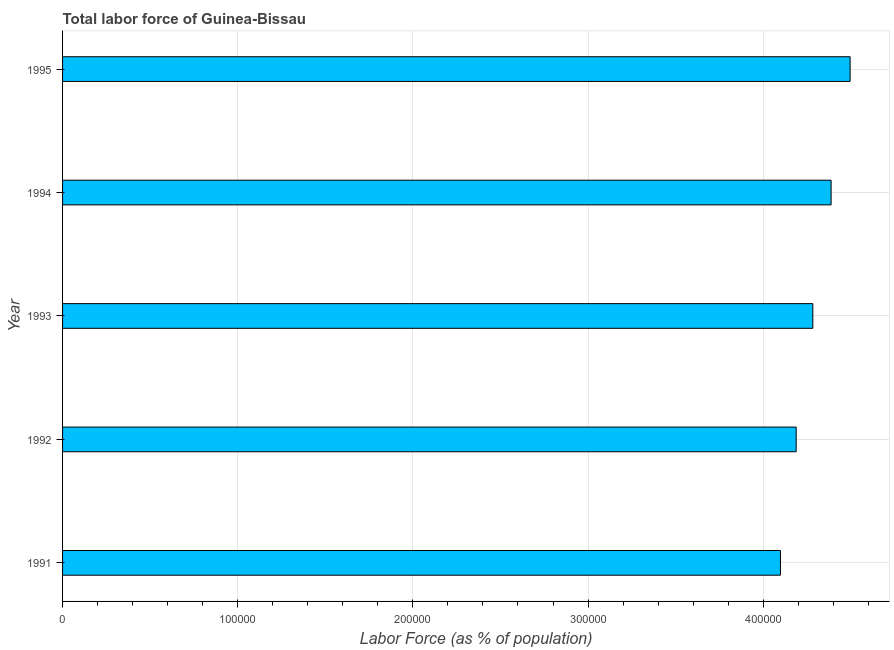Does the graph contain grids?
Make the answer very short. Yes. What is the title of the graph?
Your answer should be very brief. Total labor force of Guinea-Bissau. What is the label or title of the X-axis?
Your answer should be very brief. Labor Force (as % of population). What is the total labor force in 1992?
Your response must be concise. 4.19e+05. Across all years, what is the maximum total labor force?
Offer a terse response. 4.50e+05. Across all years, what is the minimum total labor force?
Make the answer very short. 4.10e+05. In which year was the total labor force maximum?
Give a very brief answer. 1995. What is the sum of the total labor force?
Provide a short and direct response. 2.15e+06. What is the difference between the total labor force in 1991 and 1992?
Provide a short and direct response. -8973. What is the average total labor force per year?
Make the answer very short. 4.29e+05. What is the median total labor force?
Your answer should be compact. 4.28e+05. In how many years, is the total labor force greater than 300000 %?
Your answer should be very brief. 5. Is the total labor force in 1993 less than that in 1995?
Your response must be concise. Yes. Is the difference between the total labor force in 1991 and 1993 greater than the difference between any two years?
Make the answer very short. No. What is the difference between the highest and the second highest total labor force?
Make the answer very short. 1.09e+04. What is the difference between the highest and the lowest total labor force?
Offer a terse response. 3.98e+04. How many years are there in the graph?
Provide a succinct answer. 5. Are the values on the major ticks of X-axis written in scientific E-notation?
Ensure brevity in your answer.  No. What is the Labor Force (as % of population) in 1991?
Your response must be concise. 4.10e+05. What is the Labor Force (as % of population) of 1992?
Ensure brevity in your answer.  4.19e+05. What is the Labor Force (as % of population) of 1993?
Offer a terse response. 4.28e+05. What is the Labor Force (as % of population) in 1994?
Ensure brevity in your answer.  4.39e+05. What is the Labor Force (as % of population) of 1995?
Offer a terse response. 4.50e+05. What is the difference between the Labor Force (as % of population) in 1991 and 1992?
Give a very brief answer. -8973. What is the difference between the Labor Force (as % of population) in 1991 and 1993?
Your answer should be very brief. -1.85e+04. What is the difference between the Labor Force (as % of population) in 1991 and 1994?
Your answer should be compact. -2.89e+04. What is the difference between the Labor Force (as % of population) in 1991 and 1995?
Give a very brief answer. -3.98e+04. What is the difference between the Labor Force (as % of population) in 1992 and 1993?
Provide a succinct answer. -9519. What is the difference between the Labor Force (as % of population) in 1992 and 1994?
Your answer should be very brief. -1.99e+04. What is the difference between the Labor Force (as % of population) in 1992 and 1995?
Provide a short and direct response. -3.08e+04. What is the difference between the Labor Force (as % of population) in 1993 and 1994?
Offer a very short reply. -1.04e+04. What is the difference between the Labor Force (as % of population) in 1993 and 1995?
Your response must be concise. -2.13e+04. What is the difference between the Labor Force (as % of population) in 1994 and 1995?
Give a very brief answer. -1.09e+04. What is the ratio of the Labor Force (as % of population) in 1991 to that in 1994?
Give a very brief answer. 0.93. What is the ratio of the Labor Force (as % of population) in 1991 to that in 1995?
Provide a succinct answer. 0.91. What is the ratio of the Labor Force (as % of population) in 1992 to that in 1993?
Provide a short and direct response. 0.98. What is the ratio of the Labor Force (as % of population) in 1992 to that in 1994?
Your answer should be very brief. 0.95. What is the ratio of the Labor Force (as % of population) in 1992 to that in 1995?
Your answer should be very brief. 0.93. What is the ratio of the Labor Force (as % of population) in 1993 to that in 1994?
Give a very brief answer. 0.98. What is the ratio of the Labor Force (as % of population) in 1993 to that in 1995?
Provide a short and direct response. 0.95. What is the ratio of the Labor Force (as % of population) in 1994 to that in 1995?
Keep it short and to the point. 0.98. 